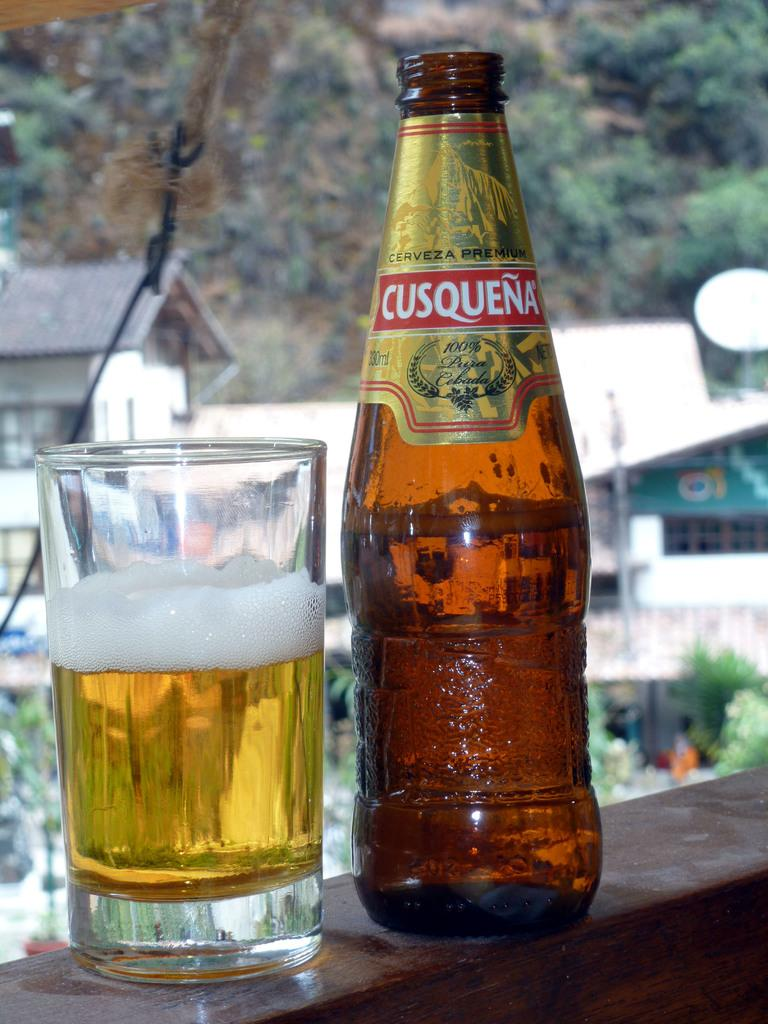<image>
Describe the image concisely. A bottle of beer has been poured from a Cusquena bottle. 